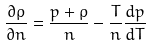Convert formula to latex. <formula><loc_0><loc_0><loc_500><loc_500>\frac { \partial \rho } { \partial n } = \frac { p + \rho } { n } - \frac { T } { n } \frac { d p } { d T }</formula> 